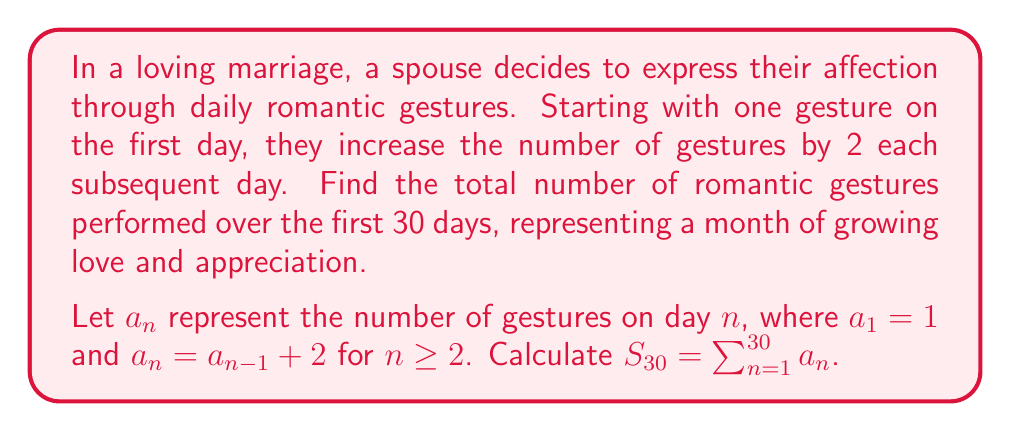Give your solution to this math problem. To solve this problem, we'll follow these steps:

1) First, let's identify the sequence:
   $a_1 = 1$
   $a_2 = 1 + 2 = 3$
   $a_3 = 3 + 2 = 5$
   $a_4 = 5 + 2 = 7$
   ...

2) We can see that this forms an arithmetic sequence with $a_1 = 1$ and common difference $d = 2$.

3) For an arithmetic sequence, the $n$-th term is given by:
   $a_n = a_1 + (n-1)d = 1 + (n-1)2 = 2n - 1$

4) The sum of an arithmetic sequence is given by:
   $S_n = \frac{n}{2}(a_1 + a_n)$

5) We need to find $S_{30}$, so:
   $S_{30} = \frac{30}{2}(a_1 + a_{30})$

6) We know $a_1 = 1$, and we can calculate $a_{30}$:
   $a_{30} = 2(30) - 1 = 59$

7) Now we can substitute these values:
   $S_{30} = \frac{30}{2}(1 + 59) = 15(60) = 900$

Therefore, the total number of romantic gestures over 30 days is 900.
Answer: 900 gestures 